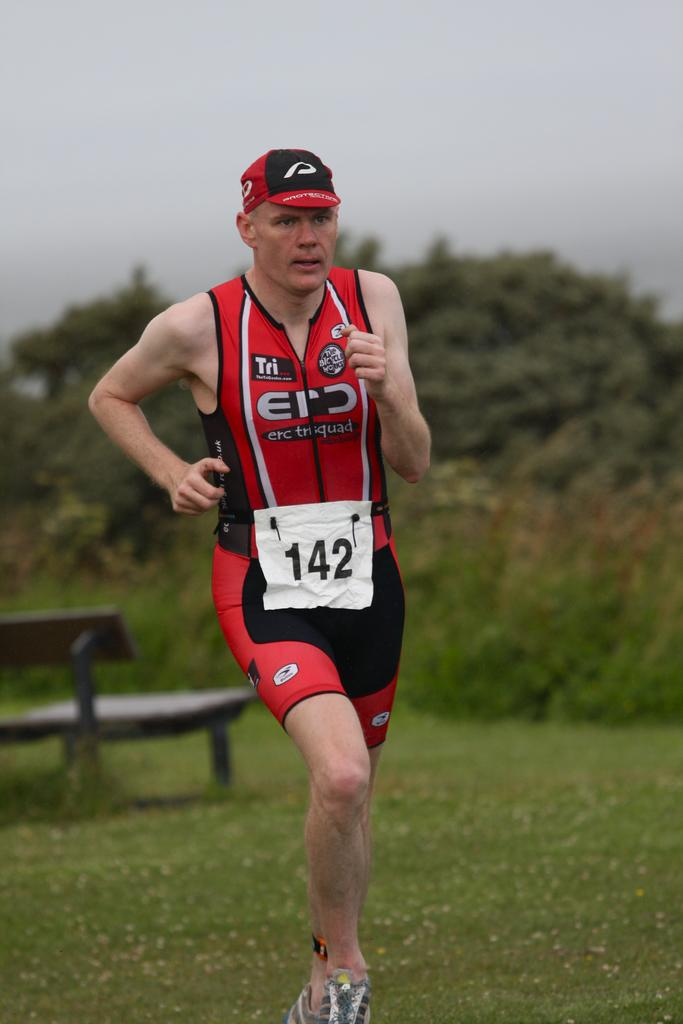<image>
Present a compact description of the photo's key features. The athlete running in a race has the number 142 around his waist. 